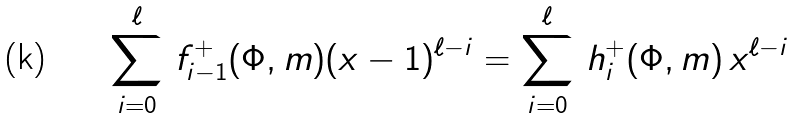Convert formula to latex. <formula><loc_0><loc_0><loc_500><loc_500>\sum _ { i = 0 } ^ { \ell } \, f ^ { + } _ { i - 1 } ( \Phi , m ) ( x - 1 ) ^ { \ell - i } = \sum _ { i = 0 } ^ { \ell } \, h ^ { + } _ { i } ( \Phi , m ) \, x ^ { \ell - i }</formula> 